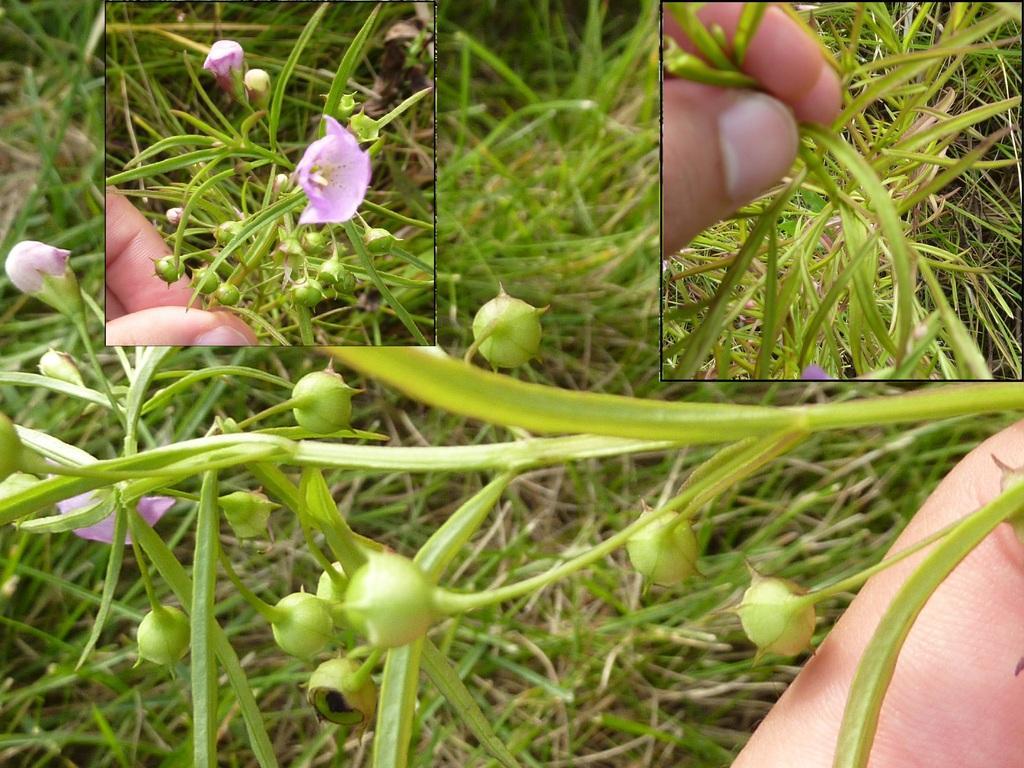How would you summarize this image in a sentence or two? In this picture we can observe some seeds of the plants. We can observe human hand holding the seeds of the plant. In the background there is some grass. We can observe a purple color flower. 